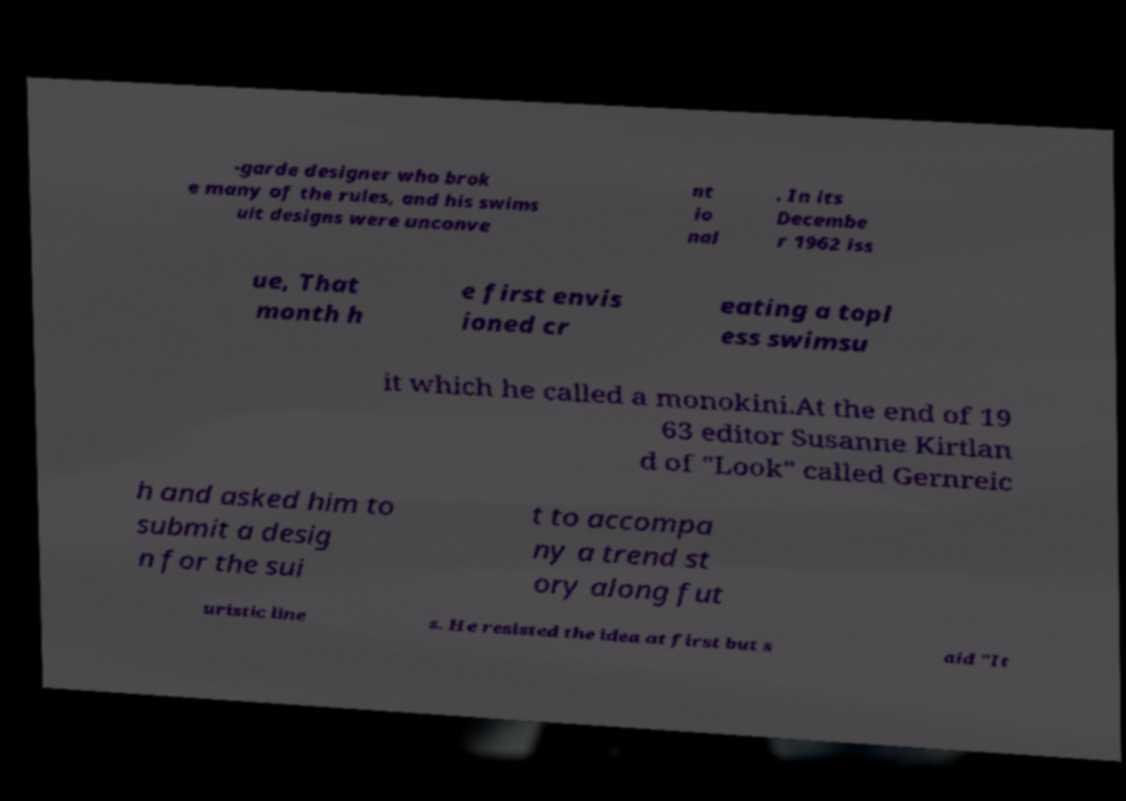Please read and relay the text visible in this image. What does it say? -garde designer who brok e many of the rules, and his swims uit designs were unconve nt io nal . In its Decembe r 1962 iss ue, That month h e first envis ioned cr eating a topl ess swimsu it which he called a monokini.At the end of 19 63 editor Susanne Kirtlan d of "Look" called Gernreic h and asked him to submit a desig n for the sui t to accompa ny a trend st ory along fut uristic line s. He resisted the idea at first but s aid "It 